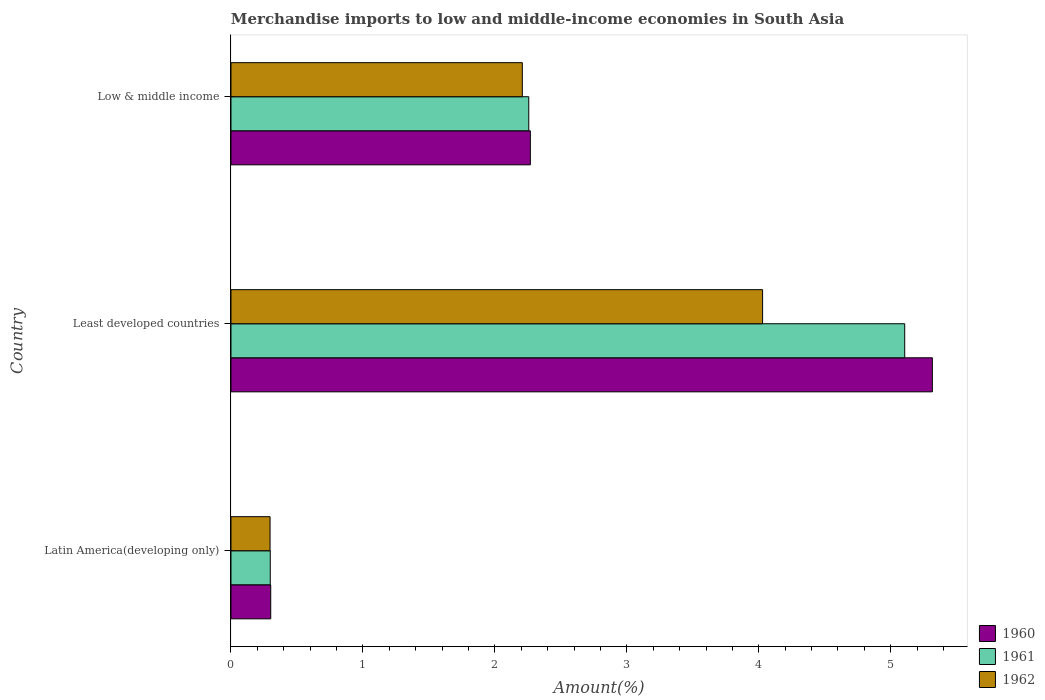How many different coloured bars are there?
Your answer should be compact. 3. Are the number of bars per tick equal to the number of legend labels?
Provide a short and direct response. Yes. Are the number of bars on each tick of the Y-axis equal?
Give a very brief answer. Yes. What is the label of the 2nd group of bars from the top?
Ensure brevity in your answer.  Least developed countries. In how many cases, is the number of bars for a given country not equal to the number of legend labels?
Your response must be concise. 0. What is the percentage of amount earned from merchandise imports in 1961 in Least developed countries?
Give a very brief answer. 5.11. Across all countries, what is the maximum percentage of amount earned from merchandise imports in 1962?
Keep it short and to the point. 4.03. Across all countries, what is the minimum percentage of amount earned from merchandise imports in 1960?
Your answer should be compact. 0.3. In which country was the percentage of amount earned from merchandise imports in 1961 maximum?
Offer a very short reply. Least developed countries. In which country was the percentage of amount earned from merchandise imports in 1960 minimum?
Offer a terse response. Latin America(developing only). What is the total percentage of amount earned from merchandise imports in 1961 in the graph?
Your answer should be compact. 7.66. What is the difference between the percentage of amount earned from merchandise imports in 1961 in Latin America(developing only) and that in Low & middle income?
Keep it short and to the point. -1.96. What is the difference between the percentage of amount earned from merchandise imports in 1960 in Latin America(developing only) and the percentage of amount earned from merchandise imports in 1961 in Least developed countries?
Keep it short and to the point. -4.8. What is the average percentage of amount earned from merchandise imports in 1962 per country?
Offer a terse response. 2.18. What is the difference between the percentage of amount earned from merchandise imports in 1960 and percentage of amount earned from merchandise imports in 1961 in Latin America(developing only)?
Your response must be concise. 0. In how many countries, is the percentage of amount earned from merchandise imports in 1962 greater than 2.8 %?
Your answer should be compact. 1. What is the ratio of the percentage of amount earned from merchandise imports in 1960 in Latin America(developing only) to that in Least developed countries?
Your answer should be very brief. 0.06. Is the percentage of amount earned from merchandise imports in 1961 in Least developed countries less than that in Low & middle income?
Your response must be concise. No. What is the difference between the highest and the second highest percentage of amount earned from merchandise imports in 1960?
Make the answer very short. 3.05. What is the difference between the highest and the lowest percentage of amount earned from merchandise imports in 1962?
Provide a short and direct response. 3.73. What does the 1st bar from the top in Latin America(developing only) represents?
Ensure brevity in your answer.  1962. Are all the bars in the graph horizontal?
Your answer should be compact. Yes. How many countries are there in the graph?
Ensure brevity in your answer.  3. What is the difference between two consecutive major ticks on the X-axis?
Your response must be concise. 1. Does the graph contain grids?
Offer a very short reply. No. Where does the legend appear in the graph?
Ensure brevity in your answer.  Bottom right. How many legend labels are there?
Your answer should be very brief. 3. How are the legend labels stacked?
Ensure brevity in your answer.  Vertical. What is the title of the graph?
Ensure brevity in your answer.  Merchandise imports to low and middle-income economies in South Asia. Does "1979" appear as one of the legend labels in the graph?
Offer a terse response. No. What is the label or title of the X-axis?
Ensure brevity in your answer.  Amount(%). What is the label or title of the Y-axis?
Give a very brief answer. Country. What is the Amount(%) of 1960 in Latin America(developing only)?
Make the answer very short. 0.3. What is the Amount(%) of 1961 in Latin America(developing only)?
Offer a terse response. 0.3. What is the Amount(%) in 1962 in Latin America(developing only)?
Give a very brief answer. 0.3. What is the Amount(%) of 1960 in Least developed countries?
Your answer should be compact. 5.32. What is the Amount(%) in 1961 in Least developed countries?
Make the answer very short. 5.11. What is the Amount(%) of 1962 in Least developed countries?
Keep it short and to the point. 4.03. What is the Amount(%) of 1960 in Low & middle income?
Your answer should be very brief. 2.27. What is the Amount(%) in 1961 in Low & middle income?
Make the answer very short. 2.26. What is the Amount(%) of 1962 in Low & middle income?
Give a very brief answer. 2.21. Across all countries, what is the maximum Amount(%) in 1960?
Offer a very short reply. 5.32. Across all countries, what is the maximum Amount(%) in 1961?
Your answer should be very brief. 5.11. Across all countries, what is the maximum Amount(%) in 1962?
Provide a short and direct response. 4.03. Across all countries, what is the minimum Amount(%) in 1960?
Give a very brief answer. 0.3. Across all countries, what is the minimum Amount(%) of 1961?
Offer a very short reply. 0.3. Across all countries, what is the minimum Amount(%) of 1962?
Your answer should be very brief. 0.3. What is the total Amount(%) of 1960 in the graph?
Your answer should be compact. 7.89. What is the total Amount(%) in 1961 in the graph?
Your answer should be very brief. 7.66. What is the total Amount(%) of 1962 in the graph?
Provide a succinct answer. 6.53. What is the difference between the Amount(%) in 1960 in Latin America(developing only) and that in Least developed countries?
Ensure brevity in your answer.  -5.01. What is the difference between the Amount(%) in 1961 in Latin America(developing only) and that in Least developed countries?
Make the answer very short. -4.81. What is the difference between the Amount(%) of 1962 in Latin America(developing only) and that in Least developed countries?
Ensure brevity in your answer.  -3.73. What is the difference between the Amount(%) of 1960 in Latin America(developing only) and that in Low & middle income?
Provide a succinct answer. -1.97. What is the difference between the Amount(%) in 1961 in Latin America(developing only) and that in Low & middle income?
Your response must be concise. -1.96. What is the difference between the Amount(%) in 1962 in Latin America(developing only) and that in Low & middle income?
Your answer should be very brief. -1.91. What is the difference between the Amount(%) in 1960 in Least developed countries and that in Low & middle income?
Give a very brief answer. 3.05. What is the difference between the Amount(%) in 1961 in Least developed countries and that in Low & middle income?
Give a very brief answer. 2.85. What is the difference between the Amount(%) of 1962 in Least developed countries and that in Low & middle income?
Offer a terse response. 1.82. What is the difference between the Amount(%) of 1960 in Latin America(developing only) and the Amount(%) of 1961 in Least developed countries?
Give a very brief answer. -4.8. What is the difference between the Amount(%) of 1960 in Latin America(developing only) and the Amount(%) of 1962 in Least developed countries?
Ensure brevity in your answer.  -3.73. What is the difference between the Amount(%) of 1961 in Latin America(developing only) and the Amount(%) of 1962 in Least developed countries?
Ensure brevity in your answer.  -3.73. What is the difference between the Amount(%) in 1960 in Latin America(developing only) and the Amount(%) in 1961 in Low & middle income?
Your answer should be very brief. -1.96. What is the difference between the Amount(%) of 1960 in Latin America(developing only) and the Amount(%) of 1962 in Low & middle income?
Offer a terse response. -1.91. What is the difference between the Amount(%) of 1961 in Latin America(developing only) and the Amount(%) of 1962 in Low & middle income?
Provide a succinct answer. -1.91. What is the difference between the Amount(%) of 1960 in Least developed countries and the Amount(%) of 1961 in Low & middle income?
Offer a very short reply. 3.06. What is the difference between the Amount(%) of 1960 in Least developed countries and the Amount(%) of 1962 in Low & middle income?
Offer a very short reply. 3.11. What is the difference between the Amount(%) of 1961 in Least developed countries and the Amount(%) of 1962 in Low & middle income?
Your response must be concise. 2.9. What is the average Amount(%) of 1960 per country?
Provide a short and direct response. 2.63. What is the average Amount(%) in 1961 per country?
Keep it short and to the point. 2.55. What is the average Amount(%) in 1962 per country?
Provide a short and direct response. 2.18. What is the difference between the Amount(%) in 1960 and Amount(%) in 1961 in Latin America(developing only)?
Keep it short and to the point. 0. What is the difference between the Amount(%) of 1960 and Amount(%) of 1962 in Latin America(developing only)?
Make the answer very short. 0.01. What is the difference between the Amount(%) of 1961 and Amount(%) of 1962 in Latin America(developing only)?
Provide a succinct answer. 0. What is the difference between the Amount(%) of 1960 and Amount(%) of 1961 in Least developed countries?
Make the answer very short. 0.21. What is the difference between the Amount(%) of 1960 and Amount(%) of 1962 in Least developed countries?
Ensure brevity in your answer.  1.29. What is the difference between the Amount(%) of 1961 and Amount(%) of 1962 in Least developed countries?
Keep it short and to the point. 1.08. What is the difference between the Amount(%) of 1960 and Amount(%) of 1961 in Low & middle income?
Give a very brief answer. 0.01. What is the difference between the Amount(%) of 1960 and Amount(%) of 1962 in Low & middle income?
Provide a short and direct response. 0.06. What is the difference between the Amount(%) in 1961 and Amount(%) in 1962 in Low & middle income?
Give a very brief answer. 0.05. What is the ratio of the Amount(%) of 1960 in Latin America(developing only) to that in Least developed countries?
Offer a terse response. 0.06. What is the ratio of the Amount(%) in 1961 in Latin America(developing only) to that in Least developed countries?
Offer a terse response. 0.06. What is the ratio of the Amount(%) in 1962 in Latin America(developing only) to that in Least developed countries?
Your answer should be very brief. 0.07. What is the ratio of the Amount(%) in 1960 in Latin America(developing only) to that in Low & middle income?
Provide a short and direct response. 0.13. What is the ratio of the Amount(%) in 1961 in Latin America(developing only) to that in Low & middle income?
Your answer should be compact. 0.13. What is the ratio of the Amount(%) of 1962 in Latin America(developing only) to that in Low & middle income?
Make the answer very short. 0.13. What is the ratio of the Amount(%) of 1960 in Least developed countries to that in Low & middle income?
Ensure brevity in your answer.  2.34. What is the ratio of the Amount(%) in 1961 in Least developed countries to that in Low & middle income?
Keep it short and to the point. 2.26. What is the ratio of the Amount(%) of 1962 in Least developed countries to that in Low & middle income?
Offer a terse response. 1.82. What is the difference between the highest and the second highest Amount(%) in 1960?
Ensure brevity in your answer.  3.05. What is the difference between the highest and the second highest Amount(%) of 1961?
Provide a short and direct response. 2.85. What is the difference between the highest and the second highest Amount(%) in 1962?
Your answer should be compact. 1.82. What is the difference between the highest and the lowest Amount(%) of 1960?
Ensure brevity in your answer.  5.01. What is the difference between the highest and the lowest Amount(%) in 1961?
Provide a short and direct response. 4.81. What is the difference between the highest and the lowest Amount(%) in 1962?
Make the answer very short. 3.73. 